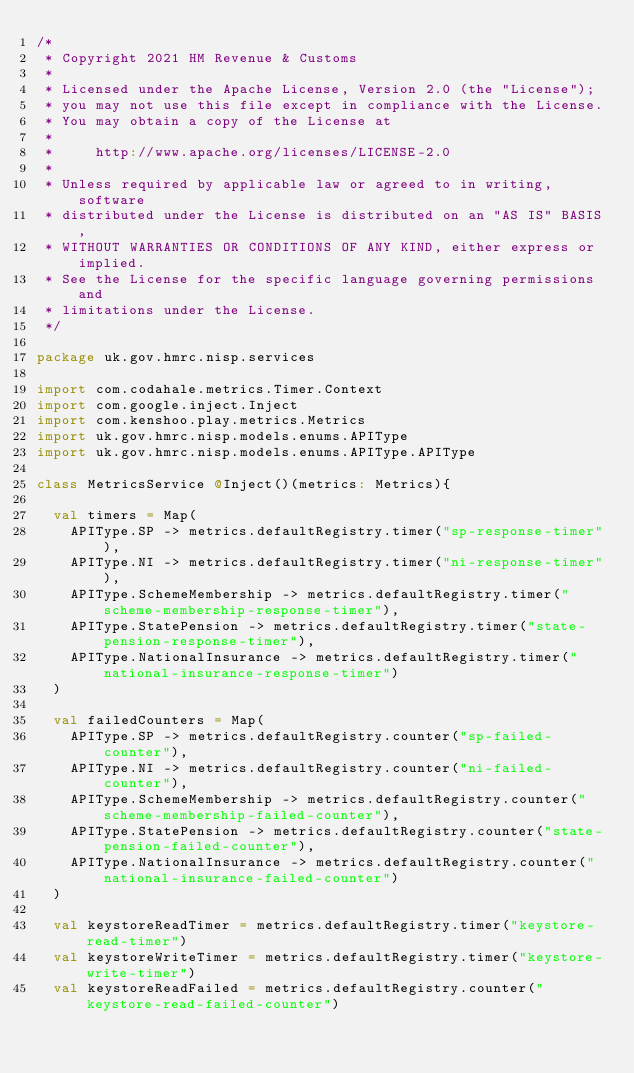Convert code to text. <code><loc_0><loc_0><loc_500><loc_500><_Scala_>/*
 * Copyright 2021 HM Revenue & Customs
 *
 * Licensed under the Apache License, Version 2.0 (the "License");
 * you may not use this file except in compliance with the License.
 * You may obtain a copy of the License at
 *
 *     http://www.apache.org/licenses/LICENSE-2.0
 *
 * Unless required by applicable law or agreed to in writing, software
 * distributed under the License is distributed on an "AS IS" BASIS,
 * WITHOUT WARRANTIES OR CONDITIONS OF ANY KIND, either express or implied.
 * See the License for the specific language governing permissions and
 * limitations under the License.
 */

package uk.gov.hmrc.nisp.services

import com.codahale.metrics.Timer.Context
import com.google.inject.Inject
import com.kenshoo.play.metrics.Metrics
import uk.gov.hmrc.nisp.models.enums.APIType
import uk.gov.hmrc.nisp.models.enums.APIType.APIType

class MetricsService @Inject()(metrics: Metrics){

  val timers = Map(
    APIType.SP -> metrics.defaultRegistry.timer("sp-response-timer"),
    APIType.NI -> metrics.defaultRegistry.timer("ni-response-timer"),
    APIType.SchemeMembership -> metrics.defaultRegistry.timer("scheme-membership-response-timer"),
    APIType.StatePension -> metrics.defaultRegistry.timer("state-pension-response-timer"),
    APIType.NationalInsurance -> metrics.defaultRegistry.timer("national-insurance-response-timer")
  )

  val failedCounters = Map(
    APIType.SP -> metrics.defaultRegistry.counter("sp-failed-counter"),
    APIType.NI -> metrics.defaultRegistry.counter("ni-failed-counter"),
    APIType.SchemeMembership -> metrics.defaultRegistry.counter("scheme-membership-failed-counter"),
    APIType.StatePension -> metrics.defaultRegistry.counter("state-pension-failed-counter"),
    APIType.NationalInsurance -> metrics.defaultRegistry.counter("national-insurance-failed-counter")
  )

  val keystoreReadTimer = metrics.defaultRegistry.timer("keystore-read-timer")
  val keystoreWriteTimer = metrics.defaultRegistry.timer("keystore-write-timer")
  val keystoreReadFailed = metrics.defaultRegistry.counter("keystore-read-failed-counter")</code> 